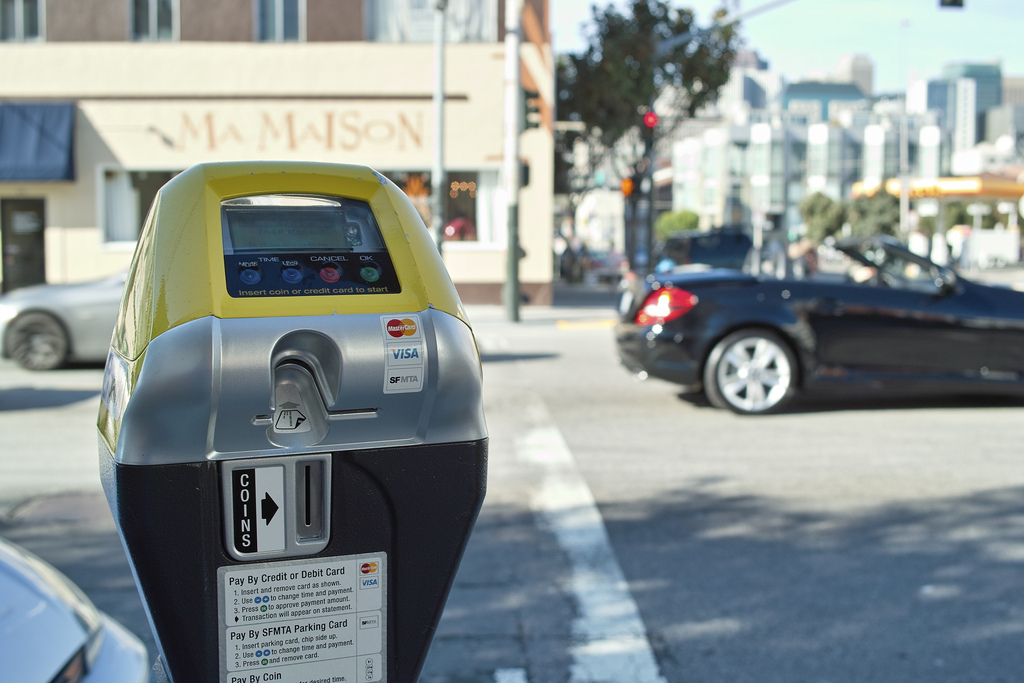What is the model of the black vehicle in the image? The model of the black vehicle appears to be a convertible sports car, possibly a Mercedes-Benz. What other colors are visible in the background of the image? In the background of the image, there are colors like beige, white, and blue from the buildings, and some greenery from trees. Imagine this scene in a different season. Describe it in detail. In autumn, the street might be covered with fallen leaves in hues of orange, yellow, and red. The trees could be displaying their vibrant autumn colors, and the atmosphere might feel cooler and crisper. The sunlight would cast a softer, golden glow across the scene, highlighting the rich textures and the seasonal transition. What if this street was actually a hidden portal to another dimension? Describe what happens when a car crosses it. As a car crosses the hidden portal, the street around it starts to shimmer and distort, like a mirage. Suddenly, the vehicle is transported into a fantastical world where towering crystal structures replace the buildings, and the sky is a vibrant swirl of colors. The laws of physics no longer apply, allowing the car to glide effortlessly above the ground. Magical creatures and surreal landscapes unfold before the driver's eyes, making for an otherworldly experience. Create a short story about a person who uses this parking meter every day. Every morning, sharegpt4v/sam, a diligent office worker, parks his car by this meter, often during the early hours when the city is just waking up. He inserts his coins, the familiar clinks echoing through the quiet street, and heads to his favorite café for a cup of coffee. Over time, sharegpt4v/sam starts to notice small, mysterious notes left on his windshield, each one containing a piece of a larger puzzle. Intrigued, he begins to piece them together, leading him on a whimsical adventure through the city’s hidden secrets and eventually to a treasure he never expected. 